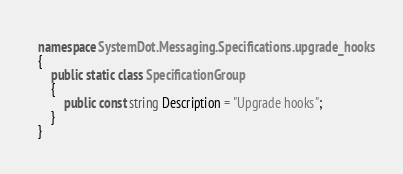Convert code to text. <code><loc_0><loc_0><loc_500><loc_500><_C#_>namespace SystemDot.Messaging.Specifications.upgrade_hooks
{
    public static class SpecificationGroup
    {
        public const string Description = "Upgrade hooks";
    }
}</code> 